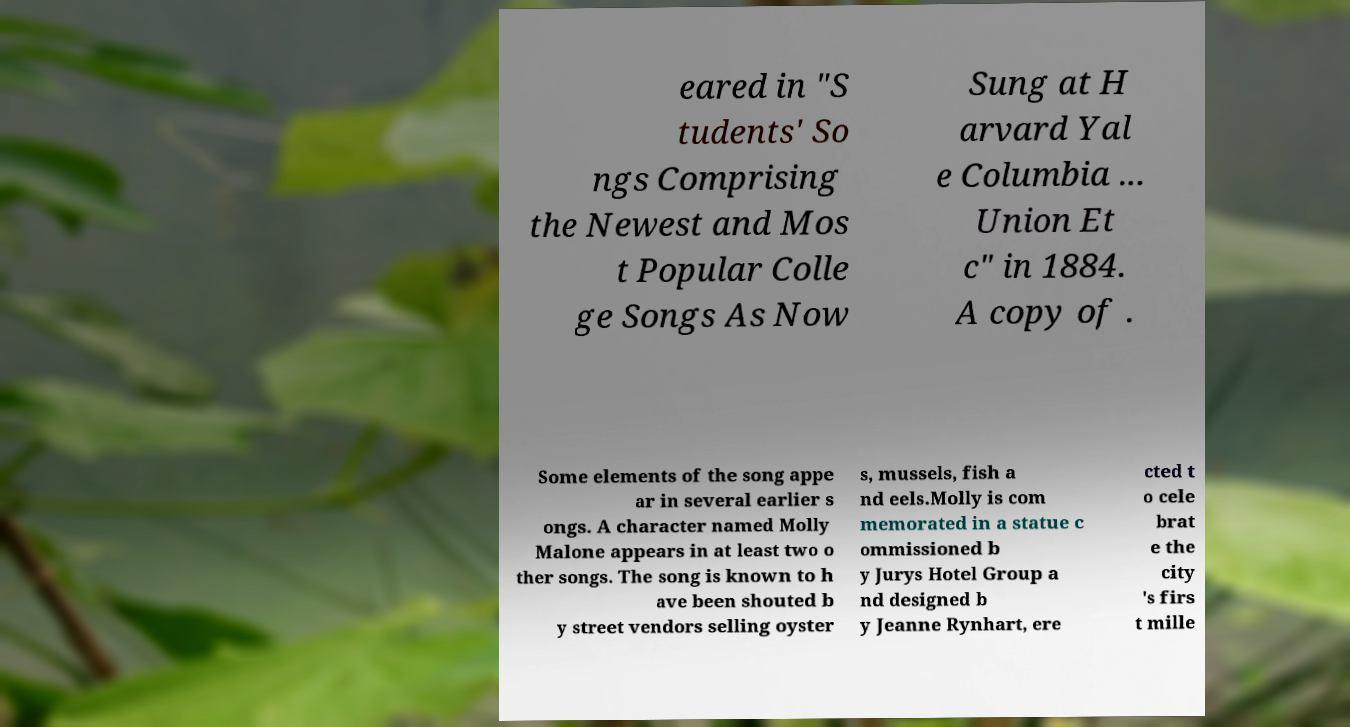Could you assist in decoding the text presented in this image and type it out clearly? eared in "S tudents' So ngs Comprising the Newest and Mos t Popular Colle ge Songs As Now Sung at H arvard Yal e Columbia ... Union Et c" in 1884. A copy of . Some elements of the song appe ar in several earlier s ongs. A character named Molly Malone appears in at least two o ther songs. The song is known to h ave been shouted b y street vendors selling oyster s, mussels, fish a nd eels.Molly is com memorated in a statue c ommissioned b y Jurys Hotel Group a nd designed b y Jeanne Rynhart, ere cted t o cele brat e the city 's firs t mille 